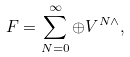<formula> <loc_0><loc_0><loc_500><loc_500>F = \sum _ { N = 0 } ^ { \infty } \oplus V ^ { N \wedge } ,</formula> 